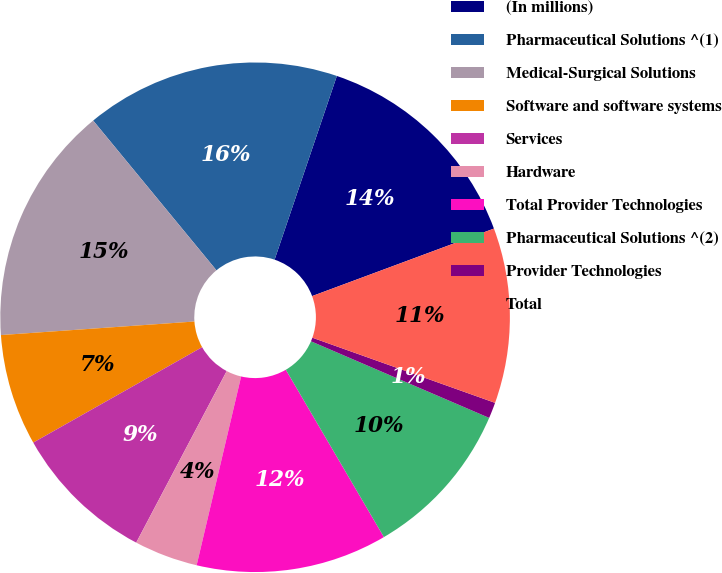Convert chart. <chart><loc_0><loc_0><loc_500><loc_500><pie_chart><fcel>(In millions)<fcel>Pharmaceutical Solutions ^(1)<fcel>Medical-Surgical Solutions<fcel>Software and software systems<fcel>Services<fcel>Hardware<fcel>Total Provider Technologies<fcel>Pharmaceutical Solutions ^(2)<fcel>Provider Technologies<fcel>Total<nl><fcel>14.14%<fcel>16.16%<fcel>15.15%<fcel>7.07%<fcel>9.09%<fcel>4.04%<fcel>12.12%<fcel>10.1%<fcel>1.01%<fcel>11.11%<nl></chart> 